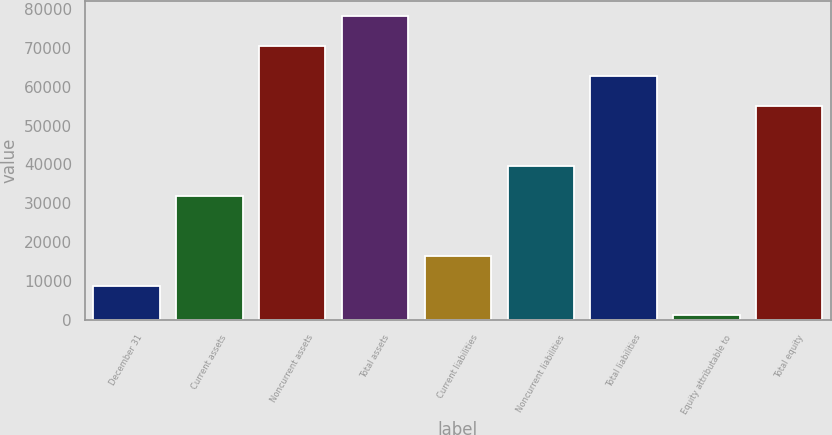Convert chart. <chart><loc_0><loc_0><loc_500><loc_500><bar_chart><fcel>December 31<fcel>Current assets<fcel>Noncurrent assets<fcel>Total assets<fcel>Current liabilities<fcel>Noncurrent liabilities<fcel>Total liabilities<fcel>Equity attributable to<fcel>Total equity<nl><fcel>8869.9<fcel>31951.6<fcel>70421.1<fcel>78115<fcel>16563.8<fcel>39645.5<fcel>62727.2<fcel>1176<fcel>55033.3<nl></chart> 